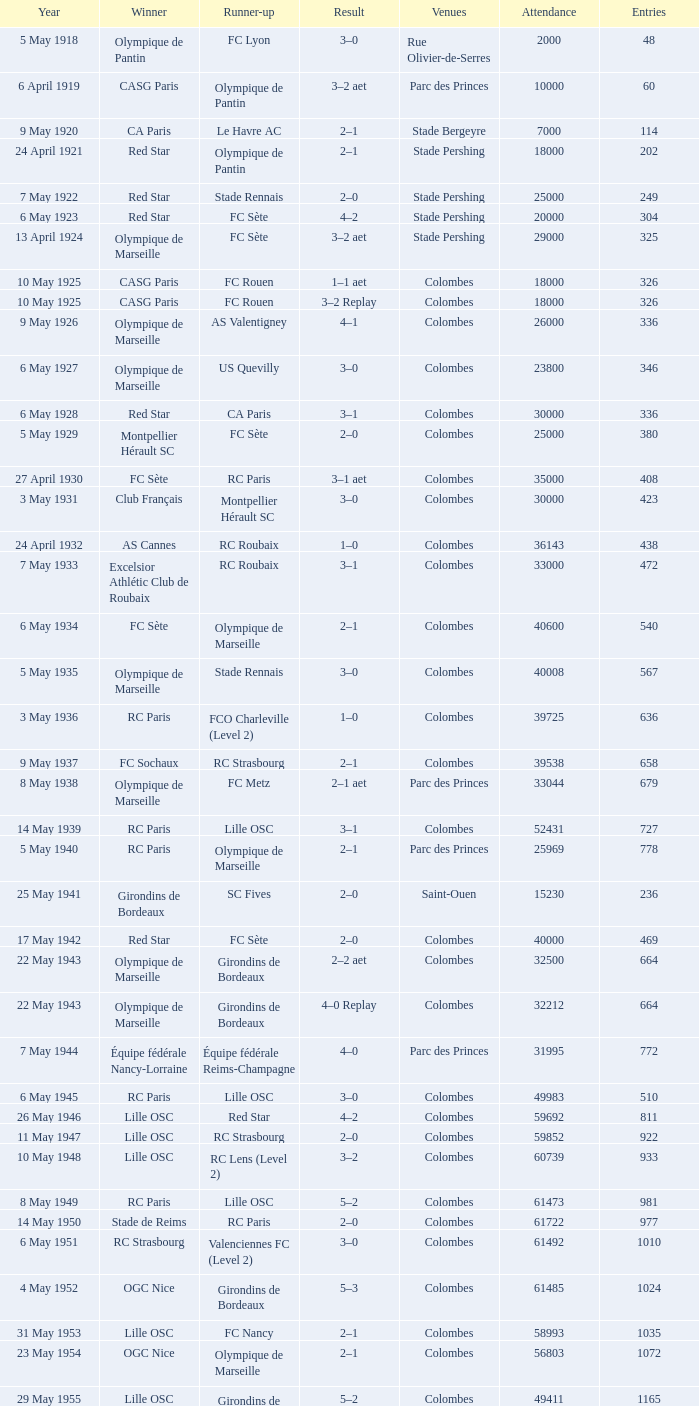What is the smallest number of entrants on record against paris saint-germain? 6394.0. 